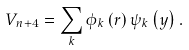<formula> <loc_0><loc_0><loc_500><loc_500>V _ { n + 4 } = \sum _ { k } \phi _ { k } \left ( r \right ) \psi _ { k } \left ( y \right ) .</formula> 